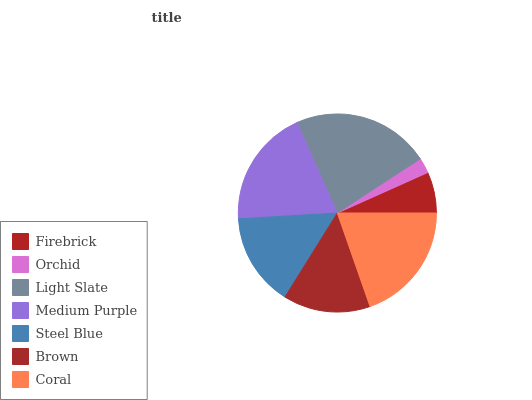Is Orchid the minimum?
Answer yes or no. Yes. Is Light Slate the maximum?
Answer yes or no. Yes. Is Light Slate the minimum?
Answer yes or no. No. Is Orchid the maximum?
Answer yes or no. No. Is Light Slate greater than Orchid?
Answer yes or no. Yes. Is Orchid less than Light Slate?
Answer yes or no. Yes. Is Orchid greater than Light Slate?
Answer yes or no. No. Is Light Slate less than Orchid?
Answer yes or no. No. Is Steel Blue the high median?
Answer yes or no. Yes. Is Steel Blue the low median?
Answer yes or no. Yes. Is Coral the high median?
Answer yes or no. No. Is Light Slate the low median?
Answer yes or no. No. 